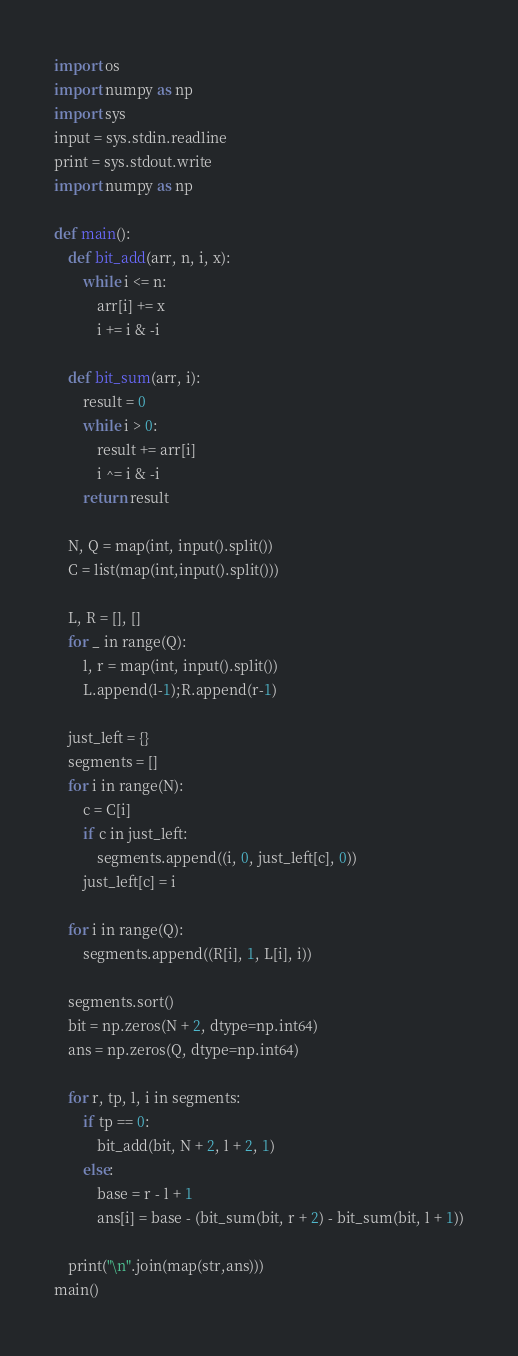Convert code to text. <code><loc_0><loc_0><loc_500><loc_500><_Python_>import os
import numpy as np
import sys
input = sys.stdin.readline
print = sys.stdout.write
import numpy as np

def main():
    def bit_add(arr, n, i, x):
        while i <= n:
            arr[i] += x
            i += i & -i

    def bit_sum(arr, i):
        result = 0
        while i > 0:
            result += arr[i]
            i ^= i & -i
        return result

    N, Q = map(int, input().split())
    C = list(map(int,input().split()))

    L, R = [], []
    for _ in range(Q):
        l, r = map(int, input().split())
        L.append(l-1);R.append(r-1)

    just_left = {}
    segments = []
    for i in range(N):
        c = C[i]
        if c in just_left:
            segments.append((i, 0, just_left[c], 0))
        just_left[c] = i

    for i in range(Q):
        segments.append((R[i], 1, L[i], i))

    segments.sort()
    bit = np.zeros(N + 2, dtype=np.int64)
    ans = np.zeros(Q, dtype=np.int64)

    for r, tp, l, i in segments:
        if tp == 0:
            bit_add(bit, N + 2, l + 2, 1)
        else:
            base = r - l + 1
            ans[i] = base - (bit_sum(bit, r + 2) - bit_sum(bit, l + 1))

    print("\n".join(map(str,ans)))
main()</code> 